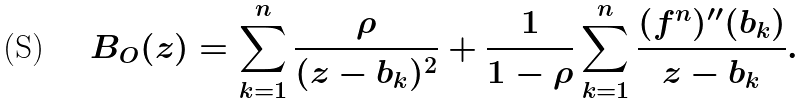Convert formula to latex. <formula><loc_0><loc_0><loc_500><loc_500>B _ { O } ( z ) = \sum _ { k = 1 } ^ { n } \frac { \rho } { ( z - b _ { k } ) ^ { 2 } } + \frac { 1 } { 1 - \rho } \sum _ { k = 1 } ^ { n } \frac { ( f ^ { n } ) ^ { \prime \prime } ( b _ { k } ) } { z - b _ { k } } .</formula> 